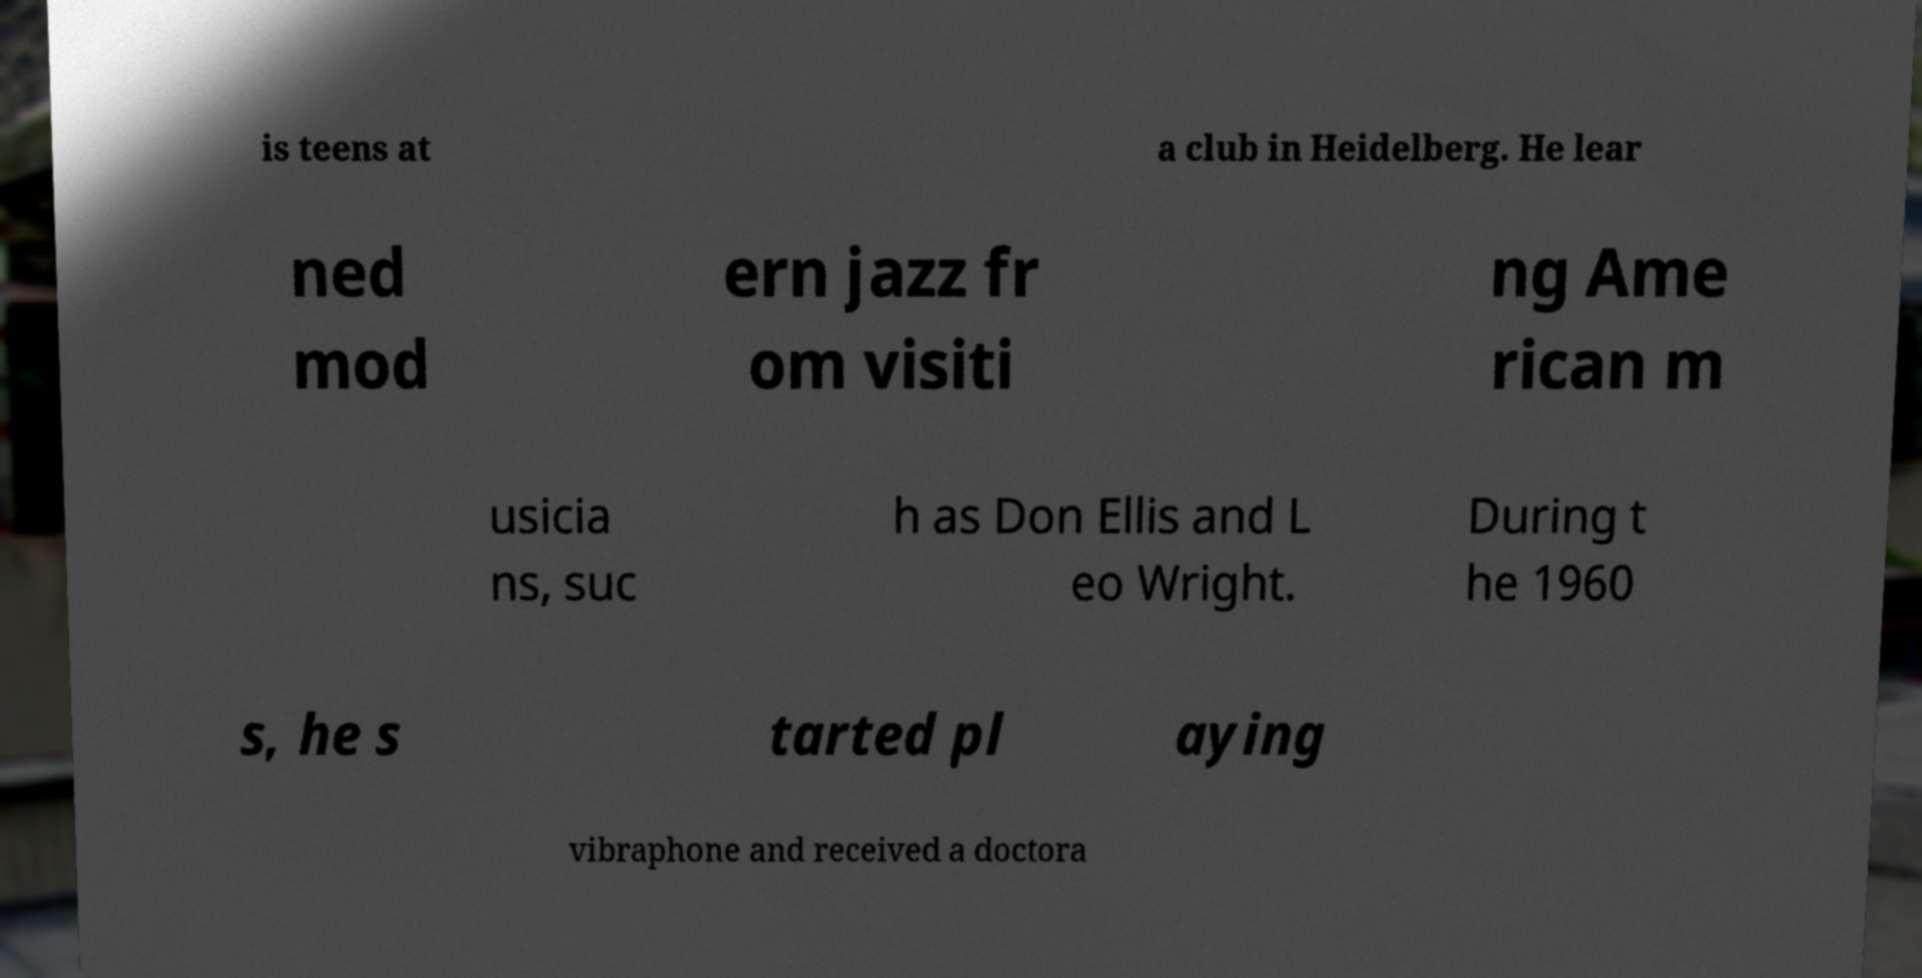Please identify and transcribe the text found in this image. is teens at a club in Heidelberg. He lear ned mod ern jazz fr om visiti ng Ame rican m usicia ns, suc h as Don Ellis and L eo Wright. During t he 1960 s, he s tarted pl aying vibraphone and received a doctora 